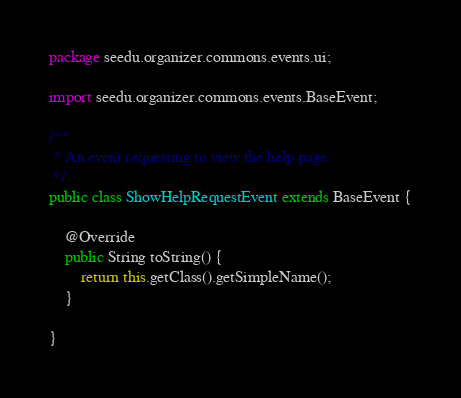<code> <loc_0><loc_0><loc_500><loc_500><_Java_>package seedu.organizer.commons.events.ui;

import seedu.organizer.commons.events.BaseEvent;

/**
 * An event requesting to view the help page.
 */
public class ShowHelpRequestEvent extends BaseEvent {

    @Override
    public String toString() {
        return this.getClass().getSimpleName();
    }

}
</code> 